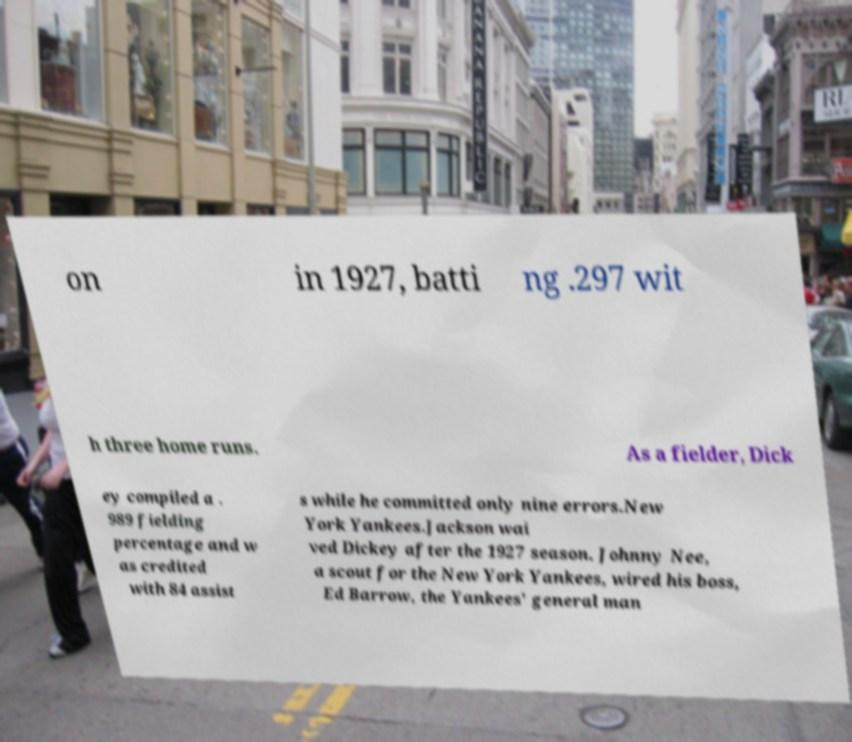Can you read and provide the text displayed in the image?This photo seems to have some interesting text. Can you extract and type it out for me? on in 1927, batti ng .297 wit h three home runs. As a fielder, Dick ey compiled a . 989 fielding percentage and w as credited with 84 assist s while he committed only nine errors.New York Yankees.Jackson wai ved Dickey after the 1927 season. Johnny Nee, a scout for the New York Yankees, wired his boss, Ed Barrow, the Yankees' general man 